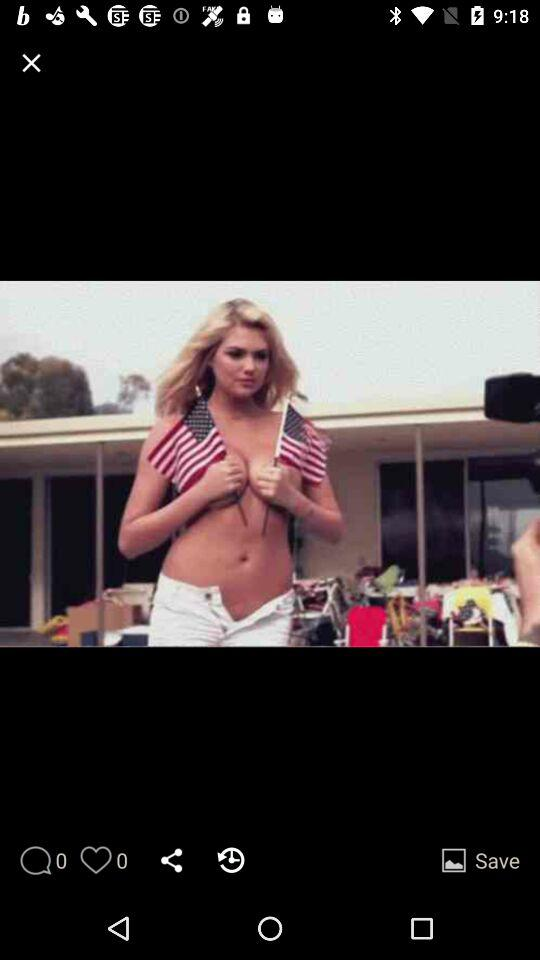What is the number of likes? The number of likes is 0. 